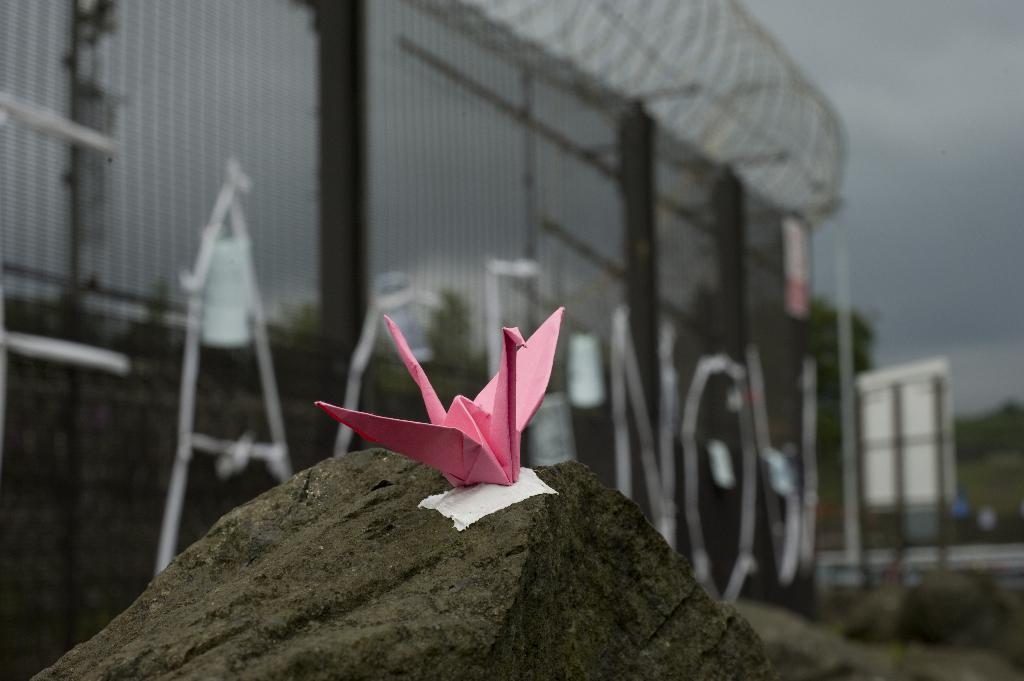How would you summarize this image in a sentence or two? In this picture there is a paper art placed on a stone. The paper is in pink in color. In the background there is a wall with the fence. Towards the right there is a board and trees. On the top there is a sky. 